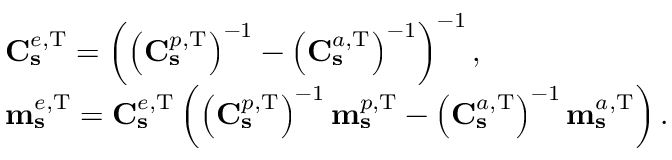<formula> <loc_0><loc_0><loc_500><loc_500>\begin{array} { r l } & { C _ { s } ^ { e , T } = \left ( \left ( C _ { s } ^ { p , T } \right ) ^ { - 1 } - \left ( C _ { s } ^ { a , T } \right ) ^ { - 1 } \right ) ^ { - 1 } , } \\ & { m _ { s } ^ { e , T } = C _ { s } ^ { e , T } \left ( \left ( C _ { s } ^ { p , T } \right ) ^ { - 1 } m _ { s } ^ { p , T } - \left ( C _ { s } ^ { a , T } \right ) ^ { - 1 } m _ { s } ^ { a , T } \right ) . } \end{array}</formula> 